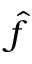Convert formula to latex. <formula><loc_0><loc_0><loc_500><loc_500>\hat { f }</formula> 